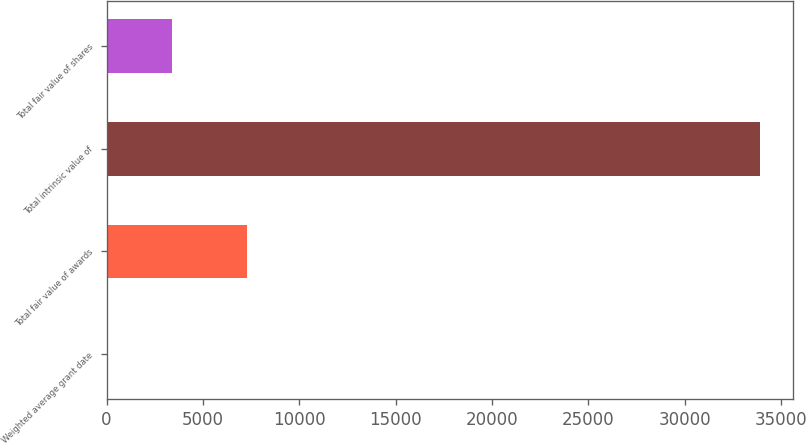<chart> <loc_0><loc_0><loc_500><loc_500><bar_chart><fcel>Weighted average grant date<fcel>Total fair value of awards<fcel>Total intrinsic value of<fcel>Total fair value of shares<nl><fcel>11.52<fcel>7281<fcel>33920<fcel>3402.37<nl></chart> 